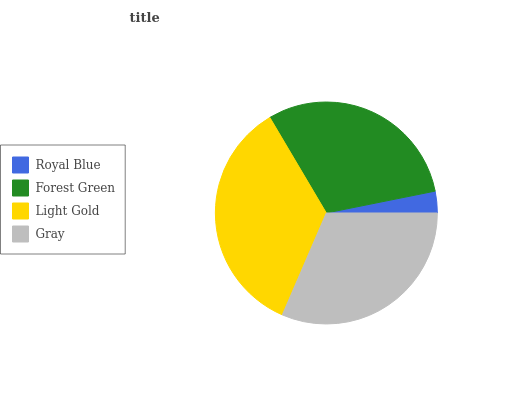Is Royal Blue the minimum?
Answer yes or no. Yes. Is Light Gold the maximum?
Answer yes or no. Yes. Is Forest Green the minimum?
Answer yes or no. No. Is Forest Green the maximum?
Answer yes or no. No. Is Forest Green greater than Royal Blue?
Answer yes or no. Yes. Is Royal Blue less than Forest Green?
Answer yes or no. Yes. Is Royal Blue greater than Forest Green?
Answer yes or no. No. Is Forest Green less than Royal Blue?
Answer yes or no. No. Is Gray the high median?
Answer yes or no. Yes. Is Forest Green the low median?
Answer yes or no. Yes. Is Forest Green the high median?
Answer yes or no. No. Is Gray the low median?
Answer yes or no. No. 